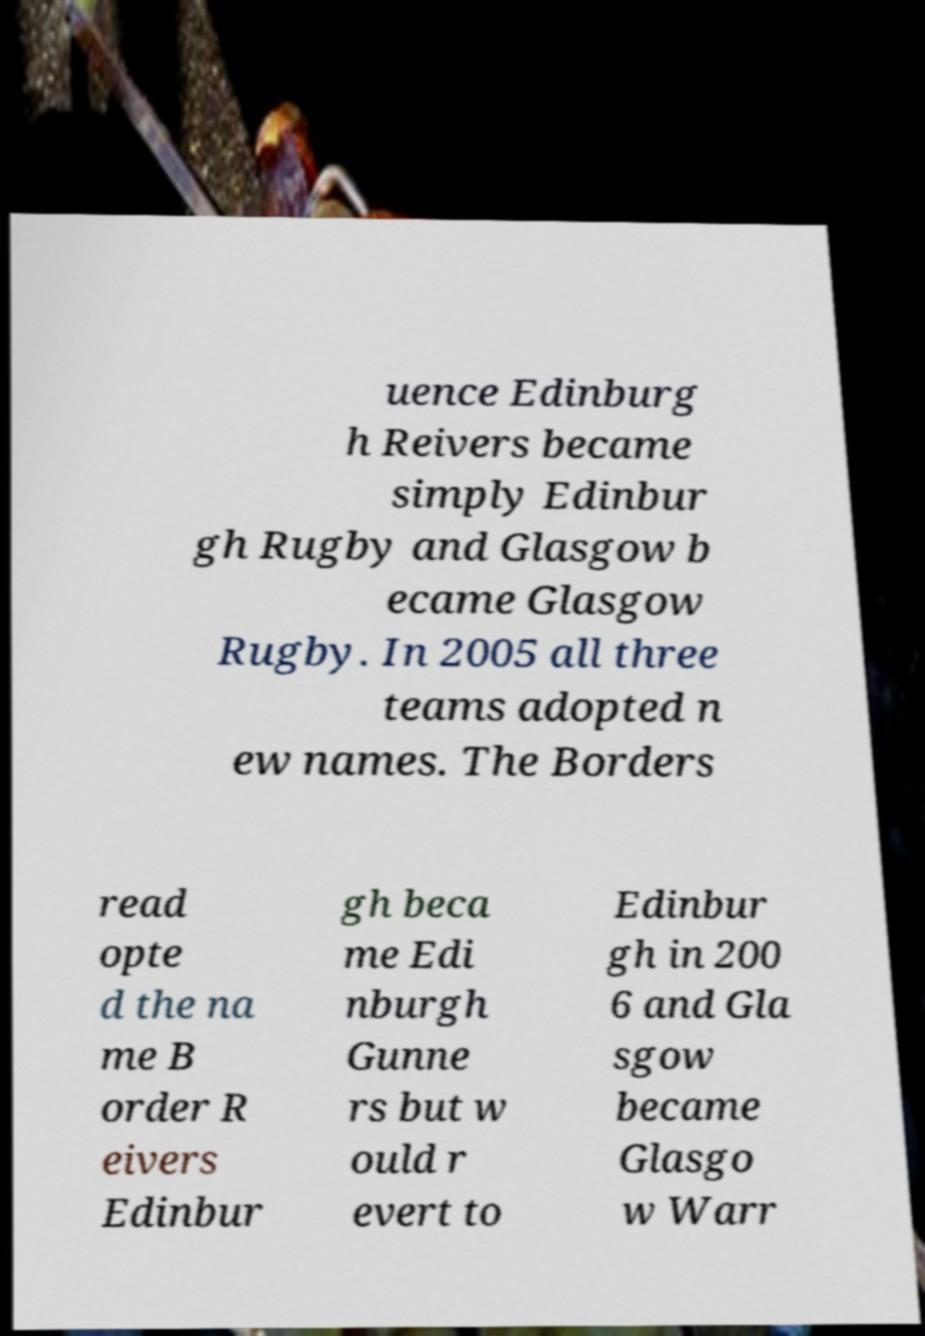I need the written content from this picture converted into text. Can you do that? uence Edinburg h Reivers became simply Edinbur gh Rugby and Glasgow b ecame Glasgow Rugby. In 2005 all three teams adopted n ew names. The Borders read opte d the na me B order R eivers Edinbur gh beca me Edi nburgh Gunne rs but w ould r evert to Edinbur gh in 200 6 and Gla sgow became Glasgo w Warr 